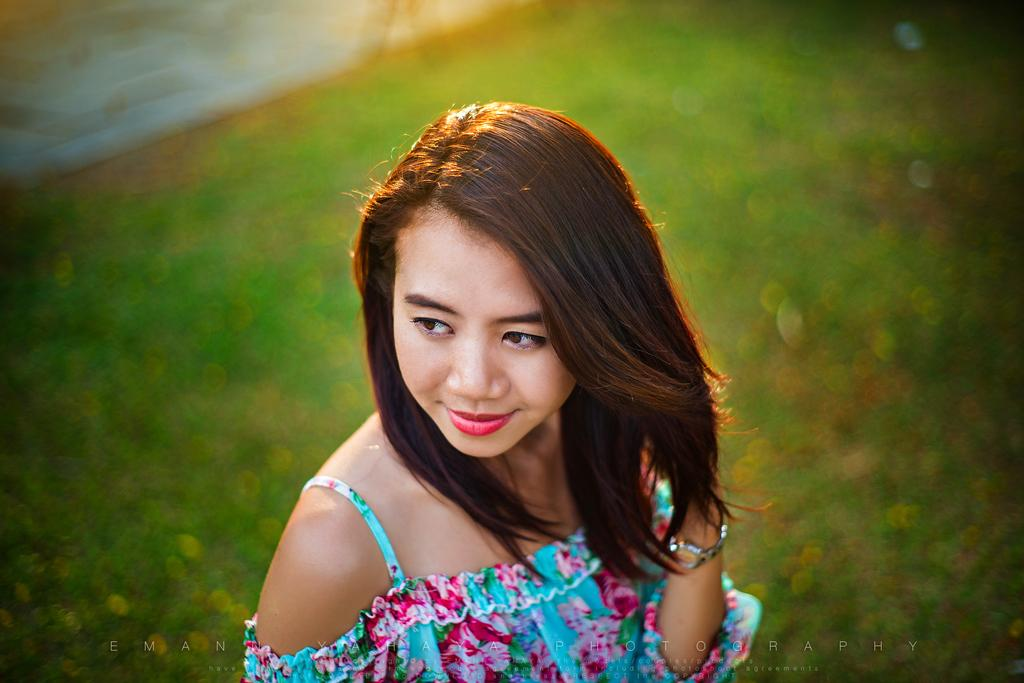Who is the main subject in the image? There is a woman in the image. What is the woman wearing? The woman is wearing a colorful dress. Can you describe any additional features of the image? There is a watermark in the image. What is the color of the background in the image? The background of the image is green. How many trees can be seen in the image? There are no trees visible in the image. What do you believe the woman is thinking in the image? We cannot determine what the woman is thinking from the image alone, as thoughts are not visible. 